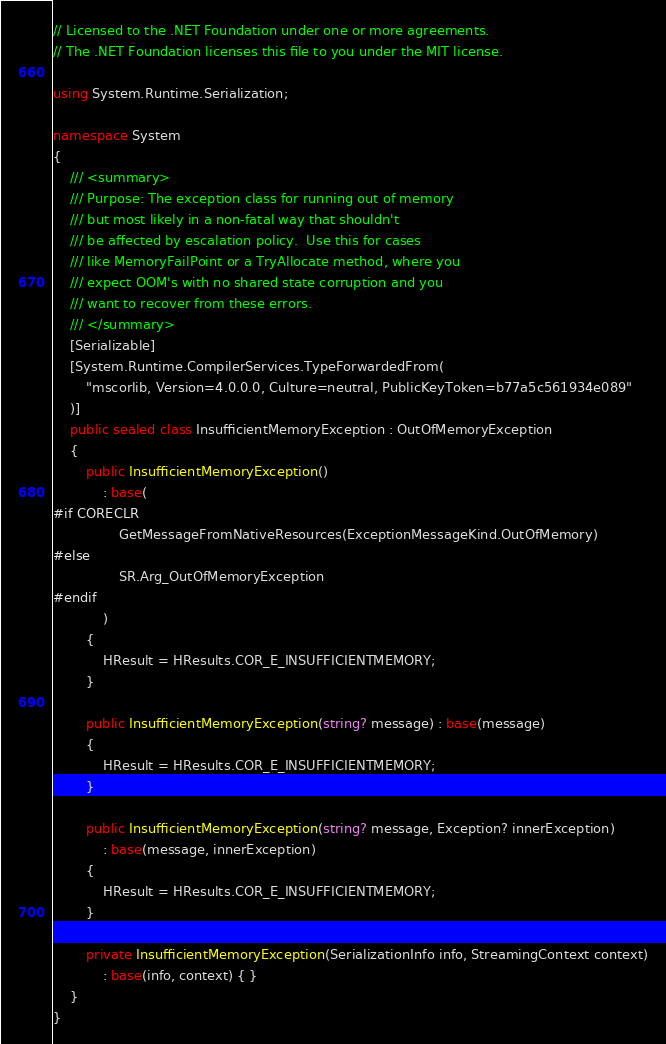Convert code to text. <code><loc_0><loc_0><loc_500><loc_500><_C#_>// Licensed to the .NET Foundation under one or more agreements.
// The .NET Foundation licenses this file to you under the MIT license.

using System.Runtime.Serialization;

namespace System
{
    /// <summary>
    /// Purpose: The exception class for running out of memory
    /// but most likely in a non-fatal way that shouldn't
    /// be affected by escalation policy.  Use this for cases
    /// like MemoryFailPoint or a TryAllocate method, where you
    /// expect OOM's with no shared state corruption and you
    /// want to recover from these errors.
    /// </summary>
    [Serializable]
    [System.Runtime.CompilerServices.TypeForwardedFrom(
        "mscorlib, Version=4.0.0.0, Culture=neutral, PublicKeyToken=b77a5c561934e089"
    )]
    public sealed class InsufficientMemoryException : OutOfMemoryException
    {
        public InsufficientMemoryException()
            : base(
#if CORECLR
                GetMessageFromNativeResources(ExceptionMessageKind.OutOfMemory)
#else
                SR.Arg_OutOfMemoryException
#endif
            )
        {
            HResult = HResults.COR_E_INSUFFICIENTMEMORY;
        }

        public InsufficientMemoryException(string? message) : base(message)
        {
            HResult = HResults.COR_E_INSUFFICIENTMEMORY;
        }

        public InsufficientMemoryException(string? message, Exception? innerException)
            : base(message, innerException)
        {
            HResult = HResults.COR_E_INSUFFICIENTMEMORY;
        }

        private InsufficientMemoryException(SerializationInfo info, StreamingContext context)
            : base(info, context) { }
    }
}
</code> 